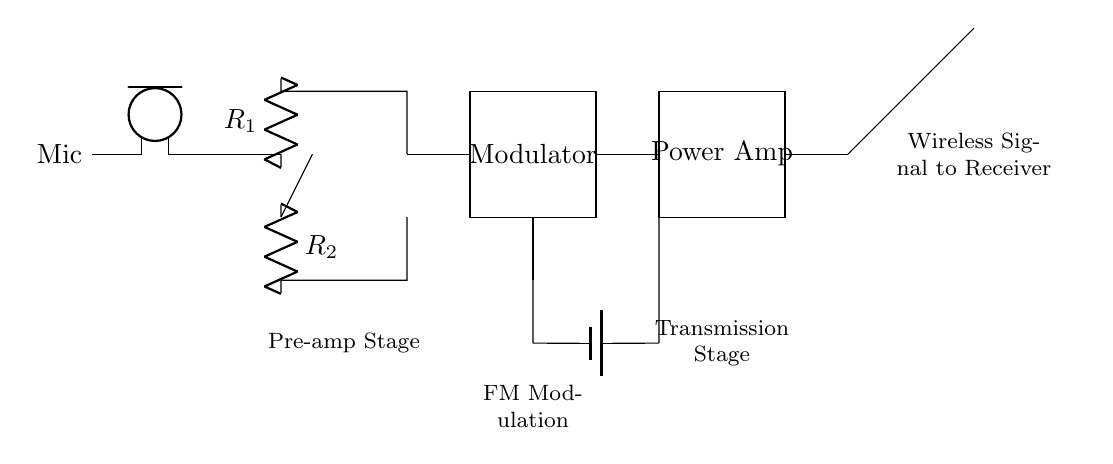What type of microphone is used in this circuit? The circuit diagram indicates the use of a 'Mic' symbol, which typically represents a dynamic or condenser microphone. This is inferred from the standard symbol used in electronic diagrams.
Answer: Mic What is the role of the pre-amplifier? The pre-amplifier, represented by an op-amp symbol in the diagram, is critical in boosting the low-level audio signal from the microphone to a level suitable for further processing. It increases the signal's strength without significantly adding noise.
Answer: Signal amplification How many resistors are present in the pre-amp stage? The preamp section shows two resistors labeled R1 and R2 connected with the op-amp. Thus, by simply counting the labeled components, we determine the total resistor count.
Answer: 2 What is the purpose of the modulator block? The modulator's function is to encode the audio signal onto a carrier frequency, facilitating its transmission in a compact format. The box labeled "Modulator" in the diagram signifies this function, allowing the subsequent power amp to enhance the modulated signal for wireless transmission.
Answer: Signal modulation What is the power source for the circuit? The battery symbol at the bottom of the diagram indicates the circuit's power source. It shows that the battery is supplying power to both the amplifier and other circuit components, making it an essential part of the circuit's operation.
Answer: Battery What component follows the oscillator in the circuit? The circuit shows that after the oscillator, directly connected is the modulator. Understanding the flow through the circuit, we can identify which component comes next in the signal processing chain, crucial for grasping how the signal is transmitted.
Answer: Modulator What type of signal does the antenna transmit? The antenna in the diagram indicates it transmits a wireless signal, which is the modulated radio frequency carrying the audio information. The note at the antenna's output clarifies the type of signal being transmitted to ensure the design's functionality for event coordination.
Answer: Wireless signal 